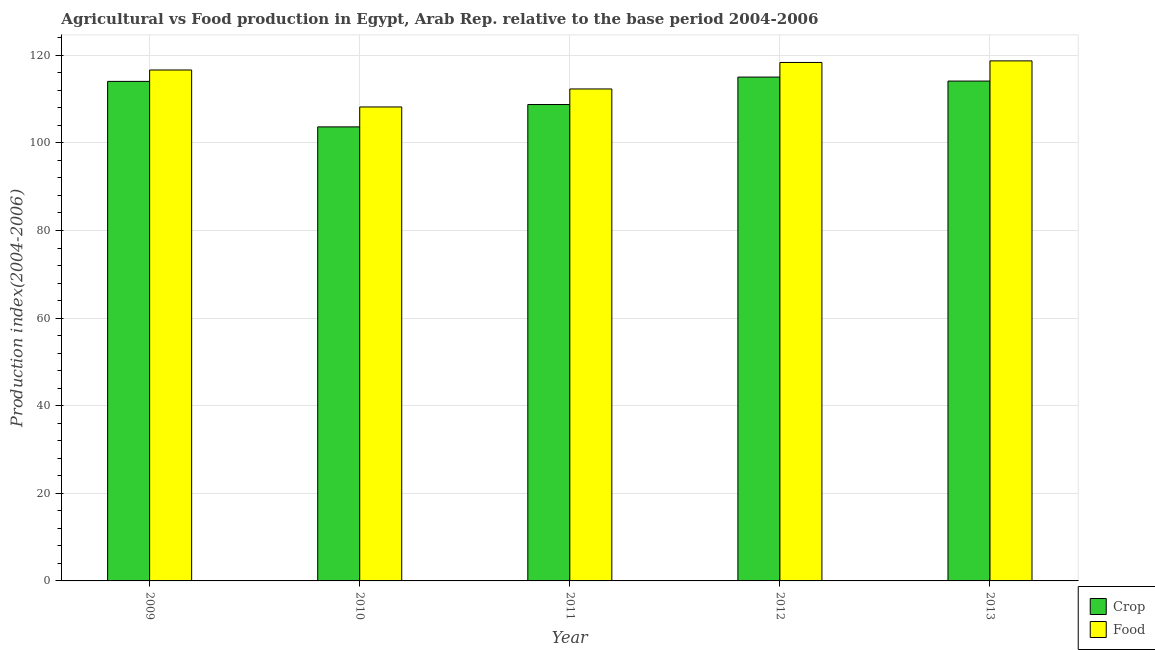How many different coloured bars are there?
Give a very brief answer. 2. Are the number of bars on each tick of the X-axis equal?
Your answer should be compact. Yes. What is the label of the 3rd group of bars from the left?
Give a very brief answer. 2011. In how many cases, is the number of bars for a given year not equal to the number of legend labels?
Ensure brevity in your answer.  0. What is the food production index in 2012?
Your answer should be compact. 118.37. Across all years, what is the maximum crop production index?
Offer a very short reply. 115.03. Across all years, what is the minimum crop production index?
Your answer should be compact. 103.66. In which year was the food production index minimum?
Ensure brevity in your answer.  2010. What is the total food production index in the graph?
Your answer should be compact. 574.28. What is the difference between the crop production index in 2010 and that in 2011?
Provide a succinct answer. -5.1. What is the difference between the crop production index in 2009 and the food production index in 2013?
Make the answer very short. -0.07. What is the average food production index per year?
Make the answer very short. 114.86. In the year 2010, what is the difference between the crop production index and food production index?
Offer a terse response. 0. What is the ratio of the food production index in 2009 to that in 2010?
Make the answer very short. 1.08. Is the difference between the food production index in 2010 and 2012 greater than the difference between the crop production index in 2010 and 2012?
Provide a short and direct response. No. What is the difference between the highest and the second highest crop production index?
Keep it short and to the point. 0.91. What is the difference between the highest and the lowest crop production index?
Offer a terse response. 11.37. What does the 2nd bar from the left in 2011 represents?
Offer a very short reply. Food. What does the 2nd bar from the right in 2013 represents?
Keep it short and to the point. Crop. How many bars are there?
Your response must be concise. 10. What is the difference between two consecutive major ticks on the Y-axis?
Offer a very short reply. 20. Are the values on the major ticks of Y-axis written in scientific E-notation?
Provide a succinct answer. No. Does the graph contain grids?
Provide a succinct answer. Yes. Where does the legend appear in the graph?
Give a very brief answer. Bottom right. How are the legend labels stacked?
Provide a short and direct response. Vertical. What is the title of the graph?
Ensure brevity in your answer.  Agricultural vs Food production in Egypt, Arab Rep. relative to the base period 2004-2006. What is the label or title of the X-axis?
Provide a short and direct response. Year. What is the label or title of the Y-axis?
Your answer should be very brief. Production index(2004-2006). What is the Production index(2004-2006) of Crop in 2009?
Your response must be concise. 114.05. What is the Production index(2004-2006) of Food in 2009?
Make the answer very short. 116.65. What is the Production index(2004-2006) of Crop in 2010?
Make the answer very short. 103.66. What is the Production index(2004-2006) in Food in 2010?
Your answer should be very brief. 108.21. What is the Production index(2004-2006) of Crop in 2011?
Provide a short and direct response. 108.76. What is the Production index(2004-2006) in Food in 2011?
Make the answer very short. 112.32. What is the Production index(2004-2006) of Crop in 2012?
Make the answer very short. 115.03. What is the Production index(2004-2006) in Food in 2012?
Offer a terse response. 118.37. What is the Production index(2004-2006) in Crop in 2013?
Make the answer very short. 114.12. What is the Production index(2004-2006) in Food in 2013?
Offer a terse response. 118.73. Across all years, what is the maximum Production index(2004-2006) of Crop?
Provide a short and direct response. 115.03. Across all years, what is the maximum Production index(2004-2006) of Food?
Your answer should be compact. 118.73. Across all years, what is the minimum Production index(2004-2006) in Crop?
Your answer should be compact. 103.66. Across all years, what is the minimum Production index(2004-2006) of Food?
Offer a very short reply. 108.21. What is the total Production index(2004-2006) of Crop in the graph?
Ensure brevity in your answer.  555.62. What is the total Production index(2004-2006) of Food in the graph?
Provide a short and direct response. 574.28. What is the difference between the Production index(2004-2006) in Crop in 2009 and that in 2010?
Give a very brief answer. 10.39. What is the difference between the Production index(2004-2006) of Food in 2009 and that in 2010?
Offer a very short reply. 8.44. What is the difference between the Production index(2004-2006) of Crop in 2009 and that in 2011?
Your answer should be very brief. 5.29. What is the difference between the Production index(2004-2006) in Food in 2009 and that in 2011?
Keep it short and to the point. 4.33. What is the difference between the Production index(2004-2006) of Crop in 2009 and that in 2012?
Ensure brevity in your answer.  -0.98. What is the difference between the Production index(2004-2006) in Food in 2009 and that in 2012?
Offer a very short reply. -1.72. What is the difference between the Production index(2004-2006) in Crop in 2009 and that in 2013?
Keep it short and to the point. -0.07. What is the difference between the Production index(2004-2006) of Food in 2009 and that in 2013?
Ensure brevity in your answer.  -2.08. What is the difference between the Production index(2004-2006) of Food in 2010 and that in 2011?
Your answer should be very brief. -4.11. What is the difference between the Production index(2004-2006) of Crop in 2010 and that in 2012?
Keep it short and to the point. -11.37. What is the difference between the Production index(2004-2006) of Food in 2010 and that in 2012?
Offer a very short reply. -10.16. What is the difference between the Production index(2004-2006) of Crop in 2010 and that in 2013?
Ensure brevity in your answer.  -10.46. What is the difference between the Production index(2004-2006) in Food in 2010 and that in 2013?
Offer a terse response. -10.52. What is the difference between the Production index(2004-2006) in Crop in 2011 and that in 2012?
Provide a succinct answer. -6.27. What is the difference between the Production index(2004-2006) of Food in 2011 and that in 2012?
Give a very brief answer. -6.05. What is the difference between the Production index(2004-2006) in Crop in 2011 and that in 2013?
Provide a succinct answer. -5.36. What is the difference between the Production index(2004-2006) in Food in 2011 and that in 2013?
Give a very brief answer. -6.41. What is the difference between the Production index(2004-2006) of Crop in 2012 and that in 2013?
Your answer should be very brief. 0.91. What is the difference between the Production index(2004-2006) of Food in 2012 and that in 2013?
Provide a succinct answer. -0.36. What is the difference between the Production index(2004-2006) of Crop in 2009 and the Production index(2004-2006) of Food in 2010?
Keep it short and to the point. 5.84. What is the difference between the Production index(2004-2006) in Crop in 2009 and the Production index(2004-2006) in Food in 2011?
Give a very brief answer. 1.73. What is the difference between the Production index(2004-2006) in Crop in 2009 and the Production index(2004-2006) in Food in 2012?
Your response must be concise. -4.32. What is the difference between the Production index(2004-2006) of Crop in 2009 and the Production index(2004-2006) of Food in 2013?
Offer a terse response. -4.68. What is the difference between the Production index(2004-2006) of Crop in 2010 and the Production index(2004-2006) of Food in 2011?
Keep it short and to the point. -8.66. What is the difference between the Production index(2004-2006) in Crop in 2010 and the Production index(2004-2006) in Food in 2012?
Your answer should be very brief. -14.71. What is the difference between the Production index(2004-2006) in Crop in 2010 and the Production index(2004-2006) in Food in 2013?
Your answer should be compact. -15.07. What is the difference between the Production index(2004-2006) in Crop in 2011 and the Production index(2004-2006) in Food in 2012?
Provide a short and direct response. -9.61. What is the difference between the Production index(2004-2006) of Crop in 2011 and the Production index(2004-2006) of Food in 2013?
Offer a terse response. -9.97. What is the average Production index(2004-2006) of Crop per year?
Your answer should be compact. 111.12. What is the average Production index(2004-2006) of Food per year?
Give a very brief answer. 114.86. In the year 2010, what is the difference between the Production index(2004-2006) of Crop and Production index(2004-2006) of Food?
Ensure brevity in your answer.  -4.55. In the year 2011, what is the difference between the Production index(2004-2006) of Crop and Production index(2004-2006) of Food?
Offer a terse response. -3.56. In the year 2012, what is the difference between the Production index(2004-2006) in Crop and Production index(2004-2006) in Food?
Provide a succinct answer. -3.34. In the year 2013, what is the difference between the Production index(2004-2006) in Crop and Production index(2004-2006) in Food?
Your answer should be very brief. -4.61. What is the ratio of the Production index(2004-2006) of Crop in 2009 to that in 2010?
Offer a very short reply. 1.1. What is the ratio of the Production index(2004-2006) in Food in 2009 to that in 2010?
Your answer should be compact. 1.08. What is the ratio of the Production index(2004-2006) in Crop in 2009 to that in 2011?
Your answer should be very brief. 1.05. What is the ratio of the Production index(2004-2006) in Food in 2009 to that in 2011?
Keep it short and to the point. 1.04. What is the ratio of the Production index(2004-2006) in Crop in 2009 to that in 2012?
Make the answer very short. 0.99. What is the ratio of the Production index(2004-2006) in Food in 2009 to that in 2012?
Provide a short and direct response. 0.99. What is the ratio of the Production index(2004-2006) in Crop in 2009 to that in 2013?
Your response must be concise. 1. What is the ratio of the Production index(2004-2006) of Food in 2009 to that in 2013?
Offer a very short reply. 0.98. What is the ratio of the Production index(2004-2006) of Crop in 2010 to that in 2011?
Your response must be concise. 0.95. What is the ratio of the Production index(2004-2006) in Food in 2010 to that in 2011?
Your answer should be compact. 0.96. What is the ratio of the Production index(2004-2006) of Crop in 2010 to that in 2012?
Ensure brevity in your answer.  0.9. What is the ratio of the Production index(2004-2006) in Food in 2010 to that in 2012?
Provide a succinct answer. 0.91. What is the ratio of the Production index(2004-2006) in Crop in 2010 to that in 2013?
Make the answer very short. 0.91. What is the ratio of the Production index(2004-2006) in Food in 2010 to that in 2013?
Your answer should be very brief. 0.91. What is the ratio of the Production index(2004-2006) in Crop in 2011 to that in 2012?
Your answer should be very brief. 0.95. What is the ratio of the Production index(2004-2006) of Food in 2011 to that in 2012?
Give a very brief answer. 0.95. What is the ratio of the Production index(2004-2006) of Crop in 2011 to that in 2013?
Make the answer very short. 0.95. What is the ratio of the Production index(2004-2006) in Food in 2011 to that in 2013?
Provide a succinct answer. 0.95. What is the ratio of the Production index(2004-2006) of Crop in 2012 to that in 2013?
Offer a very short reply. 1.01. What is the difference between the highest and the second highest Production index(2004-2006) in Crop?
Keep it short and to the point. 0.91. What is the difference between the highest and the second highest Production index(2004-2006) of Food?
Make the answer very short. 0.36. What is the difference between the highest and the lowest Production index(2004-2006) in Crop?
Your answer should be very brief. 11.37. What is the difference between the highest and the lowest Production index(2004-2006) in Food?
Give a very brief answer. 10.52. 